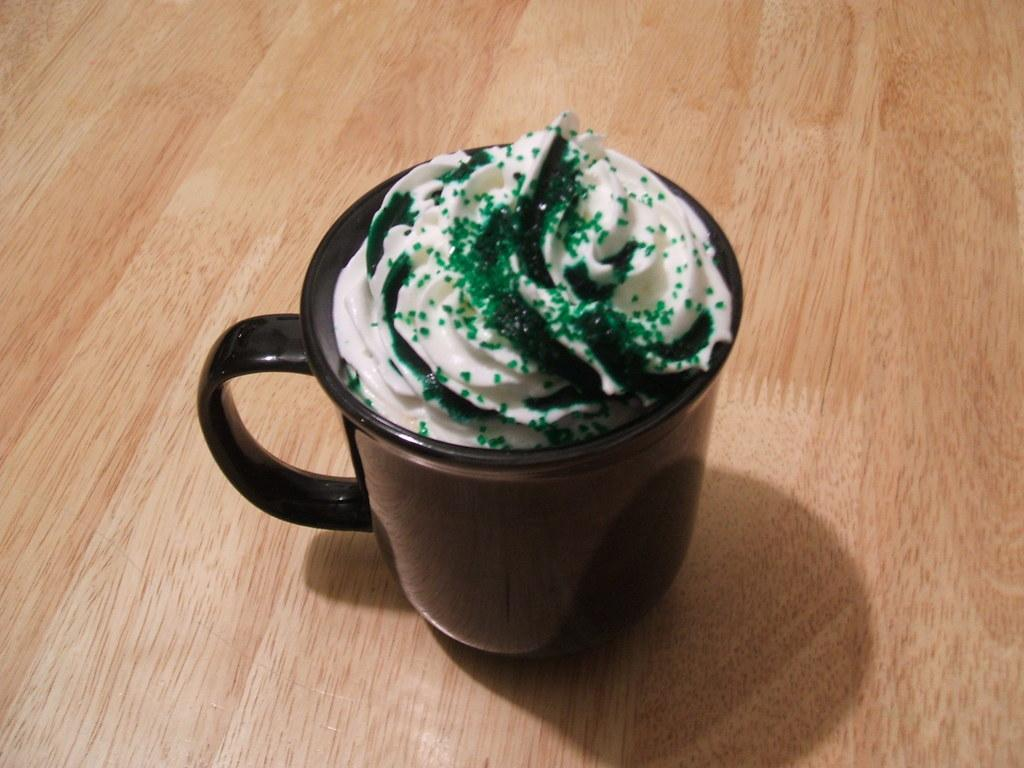What is in the cup that is visible in the image? The cup contains cream in the image. Where is the cup located in the image? The cup is placed on a table in the image. What type of veil is draped over the cup in the image? There is no veil present in the image; the cup contains cream and is placed on a table. 